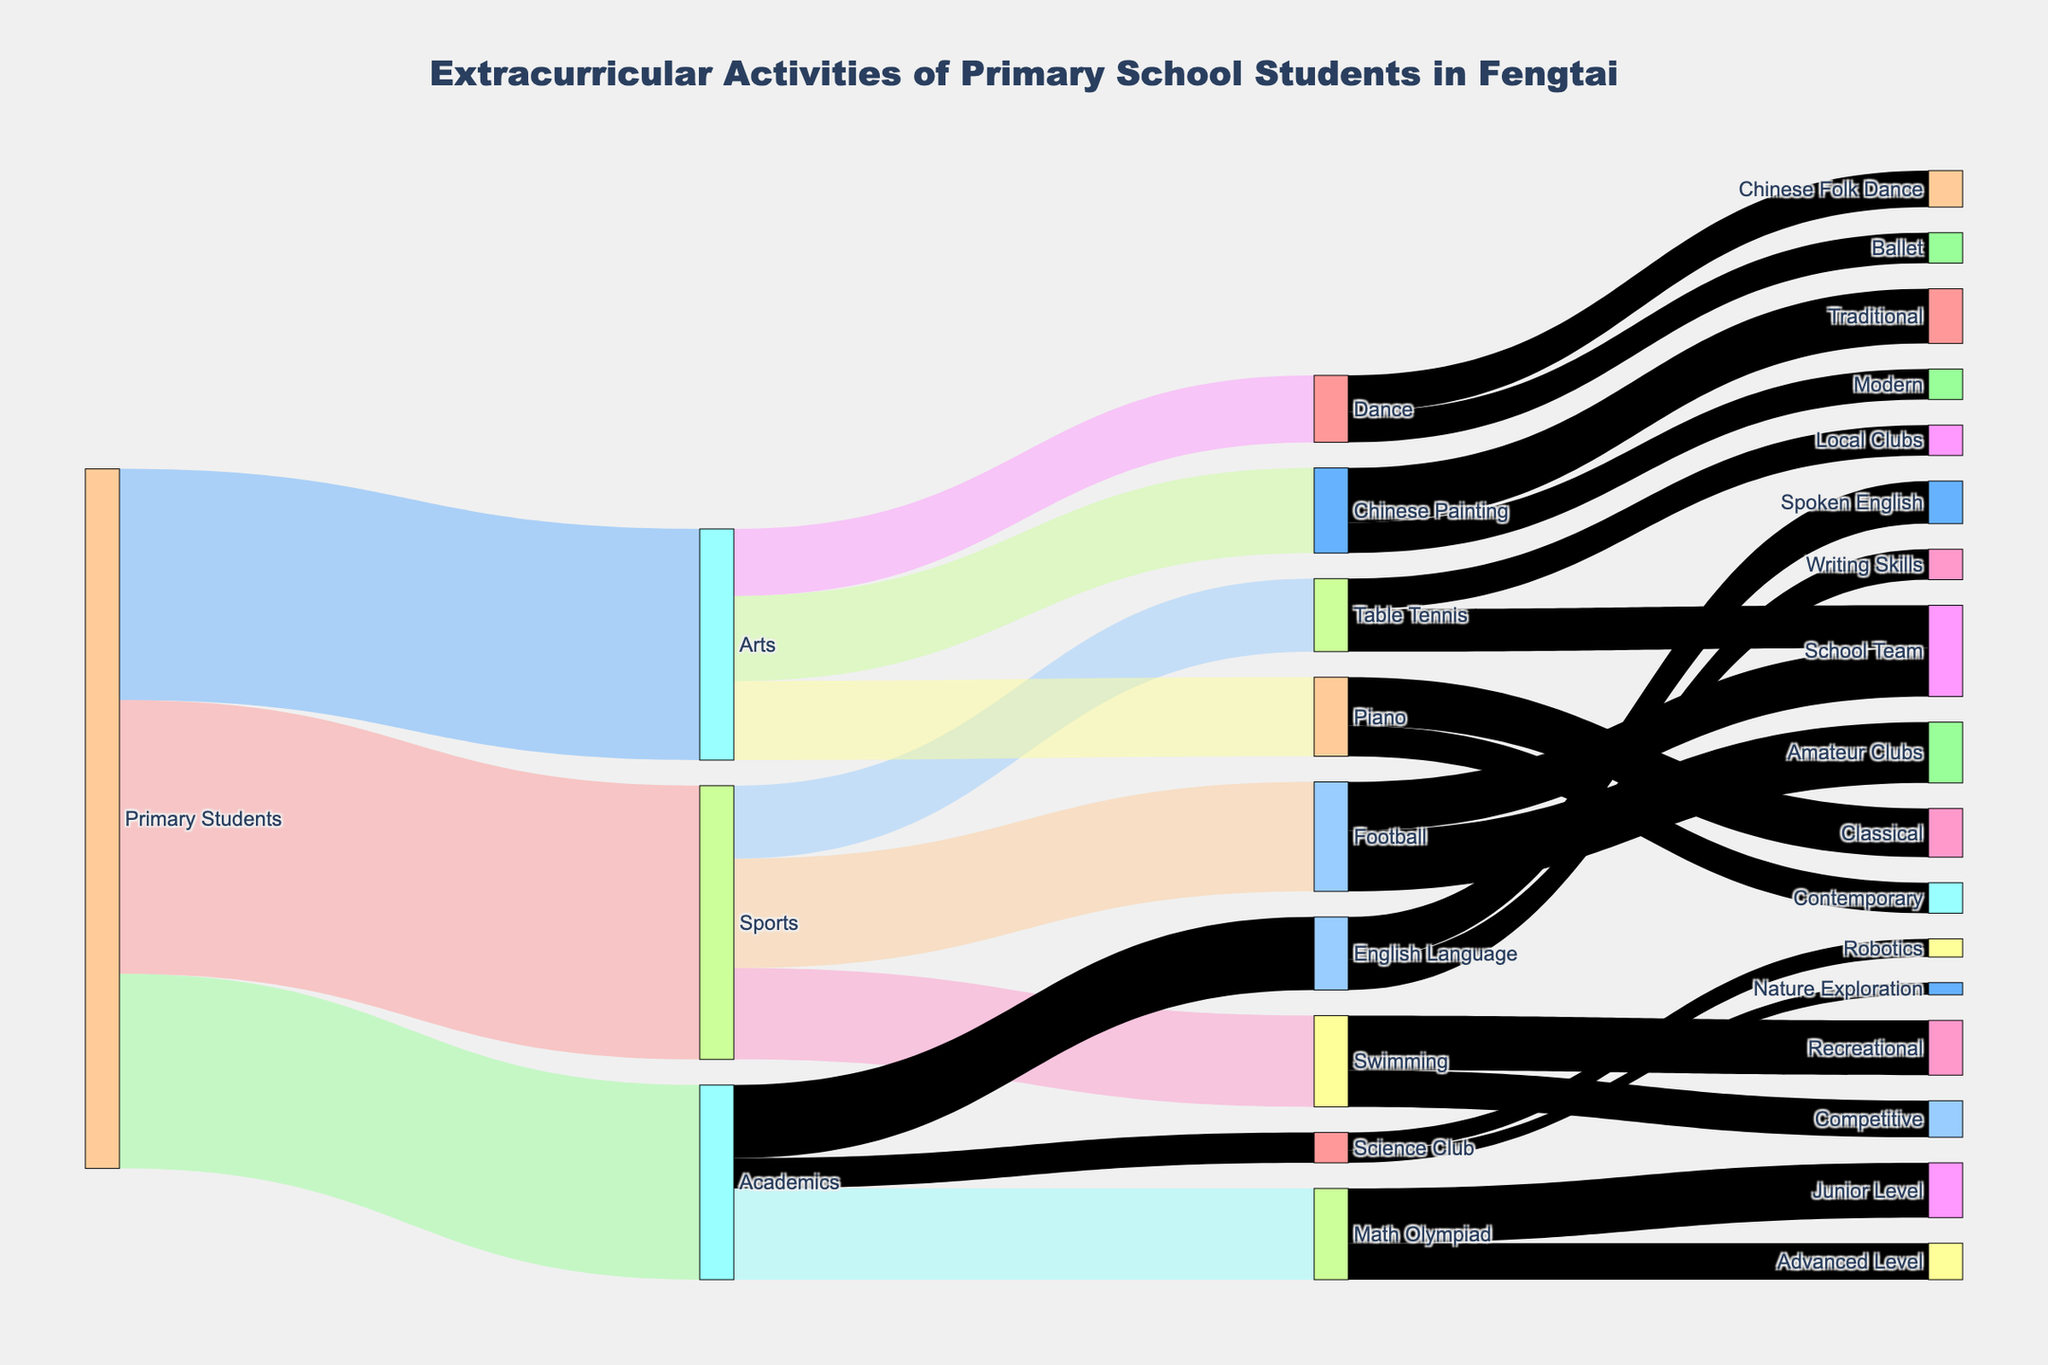how many primary school students chose sports? Look at the Sankey Diagram and find the node labeled "Sports". Follow the flow to this node from the source "Primary Students". The label on the link connecting "Primary Students" to "Sports" shows 450 students.
Answer: 450 Which extracurricular activity in sports has the highest participation? Observe the nodes under "Sports" - "Football", "Swimming", and "Table Tennis". Check the values of the outgoing links from "Sports" to these activities. "Football" has the highest value at 180.
Answer: Football What is the combined number of students participating in Chinese Painting and Piano? Locate the nodes "Chinese Painting" and "Piano" under "Arts". The values on the links from "Arts" to "Chinese Painting" and "Piano" are 140 and 130 respectively. Summing these values gives 270.
Answer: 270 How many more students are in Math Olympiad compared to Science Club? Identify the values on the links from "Academics" to "Math Olympiad" and "Science Club". These values are 150 and 50 respectively. The difference is 150 - 50, which is 100.
Answer: 100 Which has more students, Traditional Chinese Painting or Recreational Swimming? Examine the nodes "Traditional" under "Chinese Painting" and "Recreational" under "Swimming". Their values are 90 and 90 respectively, indicating an equal number.
Answer: Equal How many total students are engaged in Football at School Team and in Amateur Clubs combined? Find the node "Football" and the values leading to "School Team" and "Amateur Clubs". They are 80 and 100 respectively. Adding these gives 180.
Answer: 180 What's the total number of students involved in all the academic extracurricular activities? Check the values outgoing from "Academics" node to all its child nodes, "Math Olympiad" (150), "English Language" (120), and "Science Club" (50). Summing these values, 150 + 120 + 50, gives 320.
Answer: 320 Which has fewer participants, Ballet or Robotics club? Compare the values corresponding to "Ballet" under "Dance" (50) and "Robotics" under "Science Club" (30). Ballet has more participants.
Answer: Robotics Which extracurricular activity has the least interest among primary school students in Fengtai? Assess all the nodes and their values and identify "Nature Exploration" under "Science Club" with the value 20 as the lowest.
Answer: Nature Exploration How many students participate in School Teams for sports, including Football and Table Tennis? Look at the nodes "School Team" under "Football" and "Table Tennis". Their values are 80 and 70 respectively. Adding these values results in 150.
Answer: 150 